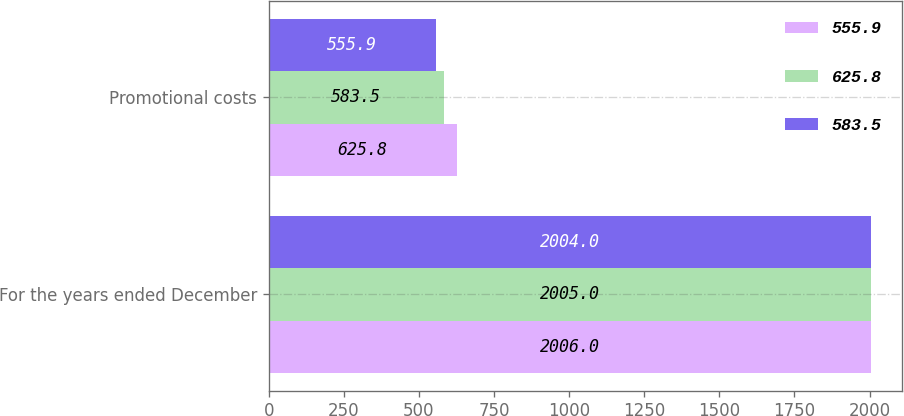Convert chart. <chart><loc_0><loc_0><loc_500><loc_500><stacked_bar_chart><ecel><fcel>For the years ended December<fcel>Promotional costs<nl><fcel>555.9<fcel>2006<fcel>625.8<nl><fcel>625.8<fcel>2005<fcel>583.5<nl><fcel>583.5<fcel>2004<fcel>555.9<nl></chart> 